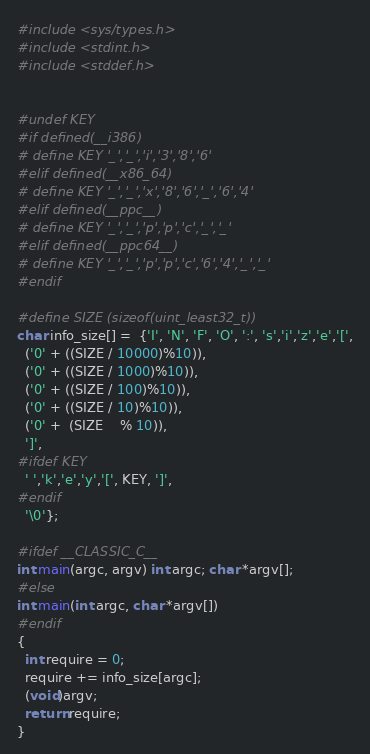<code> <loc_0><loc_0><loc_500><loc_500><_C_>#include <sys/types.h>
#include <stdint.h>
#include <stddef.h>


#undef KEY
#if defined(__i386)
# define KEY '_','_','i','3','8','6'
#elif defined(__x86_64)
# define KEY '_','_','x','8','6','_','6','4'
#elif defined(__ppc__)
# define KEY '_','_','p','p','c','_','_'
#elif defined(__ppc64__)
# define KEY '_','_','p','p','c','6','4','_','_'
#endif

#define SIZE (sizeof(uint_least32_t))
char info_size[] =  {'I', 'N', 'F', 'O', ':', 's','i','z','e','[',
  ('0' + ((SIZE / 10000)%10)),
  ('0' + ((SIZE / 1000)%10)),
  ('0' + ((SIZE / 100)%10)),
  ('0' + ((SIZE / 10)%10)),
  ('0' +  (SIZE    % 10)),
  ']',
#ifdef KEY
  ' ','k','e','y','[', KEY, ']',
#endif
  '\0'};

#ifdef __CLASSIC_C__
int main(argc, argv) int argc; char *argv[];
#else
int main(int argc, char *argv[])
#endif
{
  int require = 0;
  require += info_size[argc];
  (void)argv;
  return require;
}
</code> 